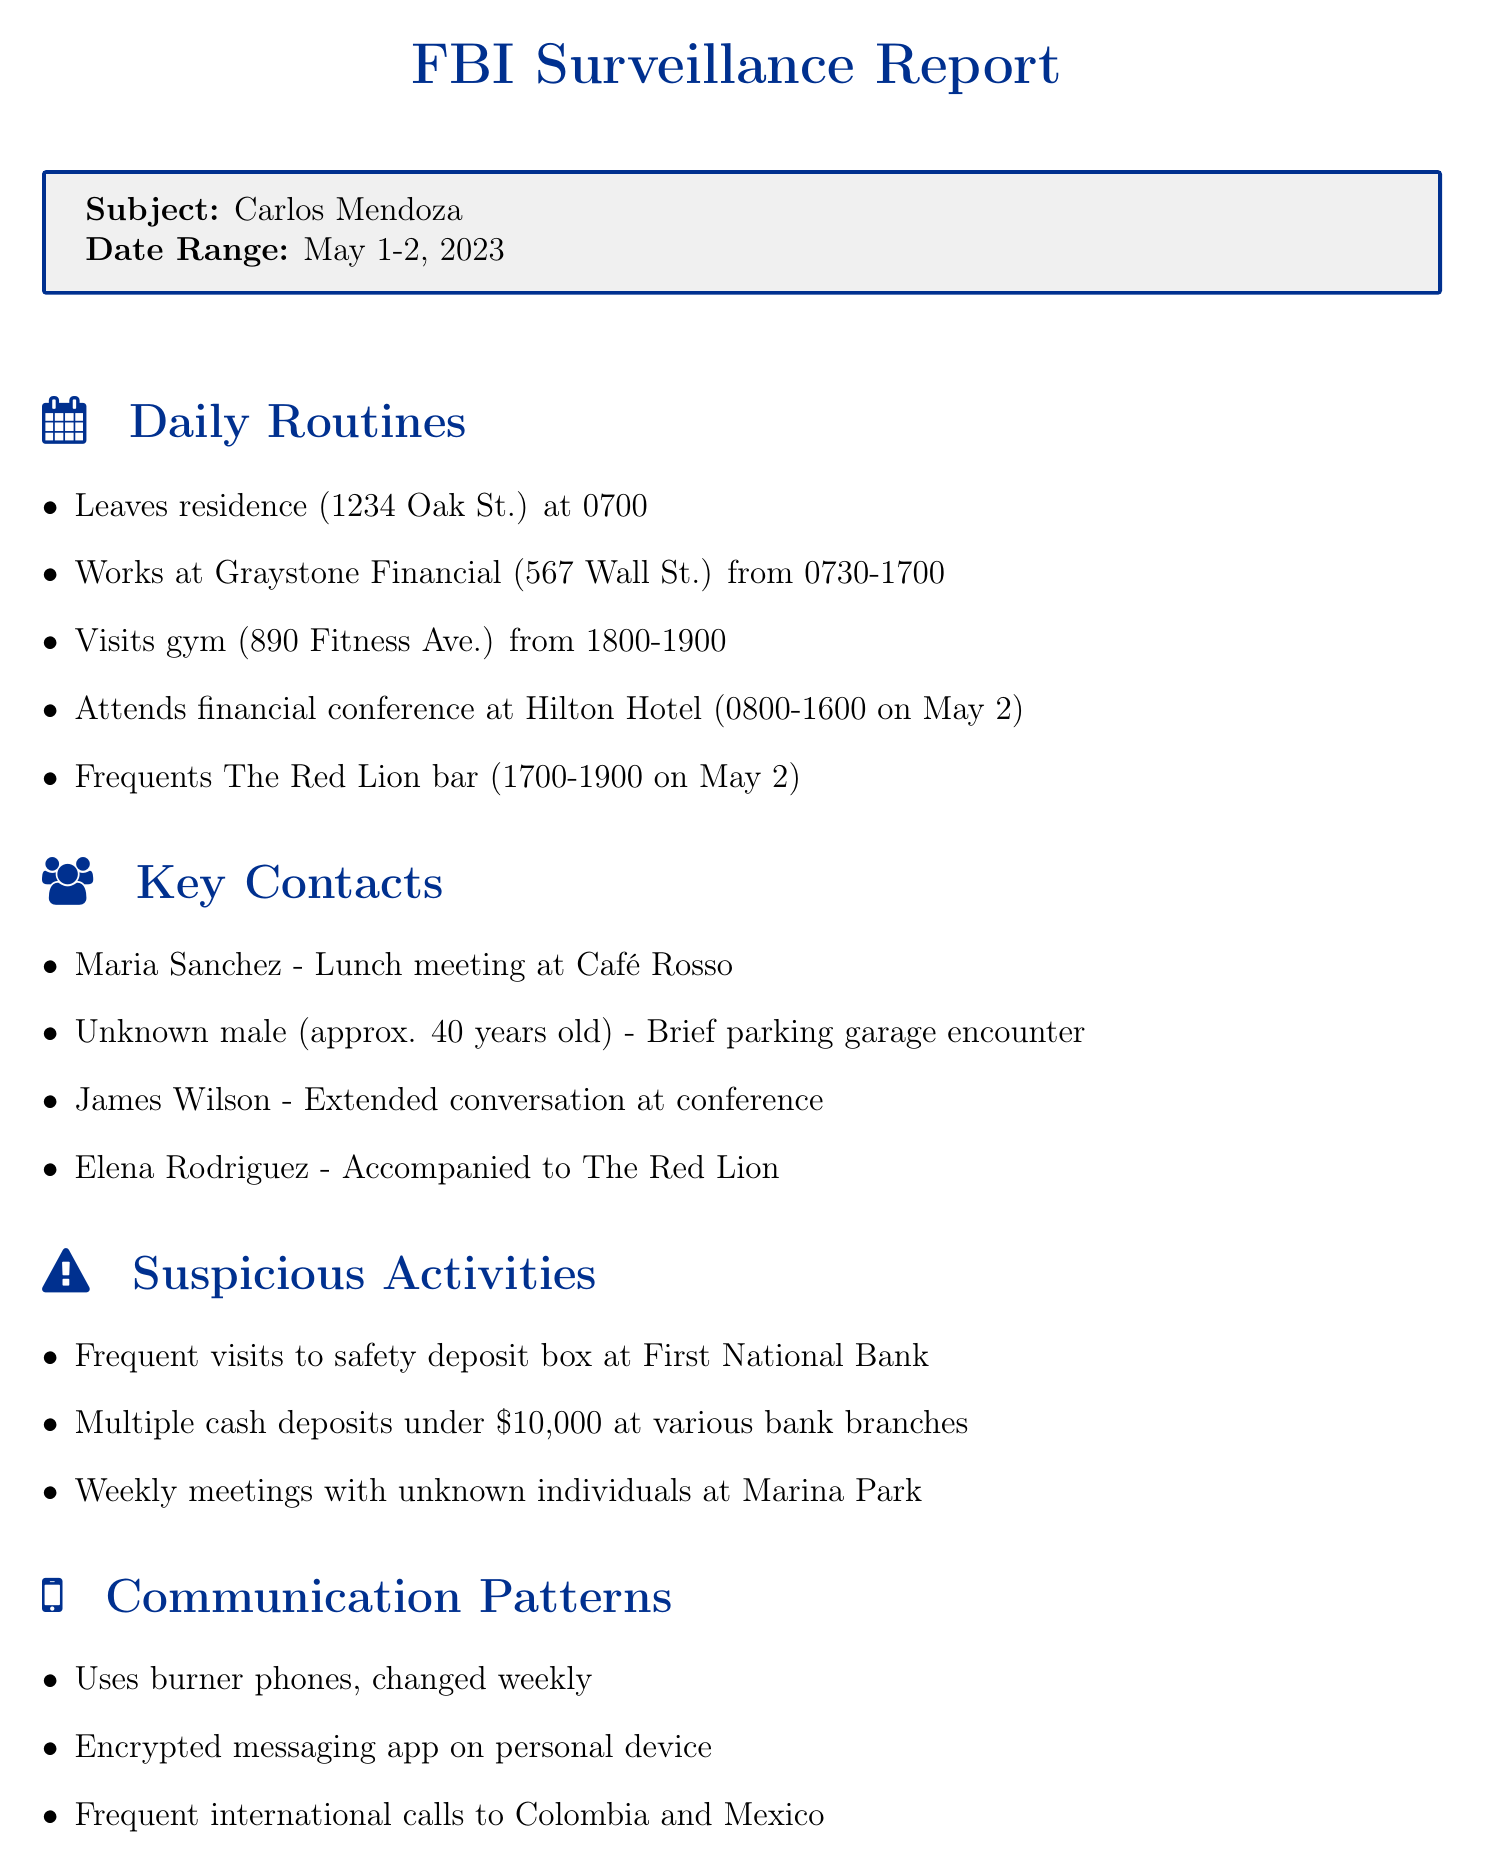What is the address of Carlos Mendoza's residence? The address is specified in the daily routines under "Leaves residence," which is 1234 Oak St.
Answer: 1234 Oak St What time does Carlos Mendoza leave his residence? The specific time is noted in the daily routine as 0700 when he leaves his residence.
Answer: 0700 Where does Carlos Mendoza work? His workplace is mentioned in the daily routines, located at Graystone Financial, 567 Wall St.
Answer: Graystone Financial, 567 Wall St Who did Carlos Mendoza meet for lunch on May 1? The key contact section specifies that he met Maria Sanchez for lunch at Café Rosso.
Answer: Maria Sanchez What suspicious activity is noted regarding Carlos Mendoza's banking habits? The surveillance log mentions multiple cash deposits under $10,000 at various bank branches.
Answer: Multiple cash deposits under $10,000 What type of phones does Carlos Mendoza use? The communication patterns section states that he uses burner phones, which he changes weekly.
Answer: Burner phones Which gambling venue is mentioned in relation to Carlos Mendoza? The potential weaknesses section indicates that he has a gambling habit observed at Stardust Casino.
Answer: Stardust Casino What time does Carlos Mendoza usually go to the gym? His gym visit is documented from 1800 to 1900 in the daily routines.
Answer: 1800-1900 What is one potential weakness of Carlos Mendoza? The document mentions a close relationship with his sister, Sofia Mendoza, as a potential weakness.
Answer: Close relationship with sister, Sofia Mendoza 